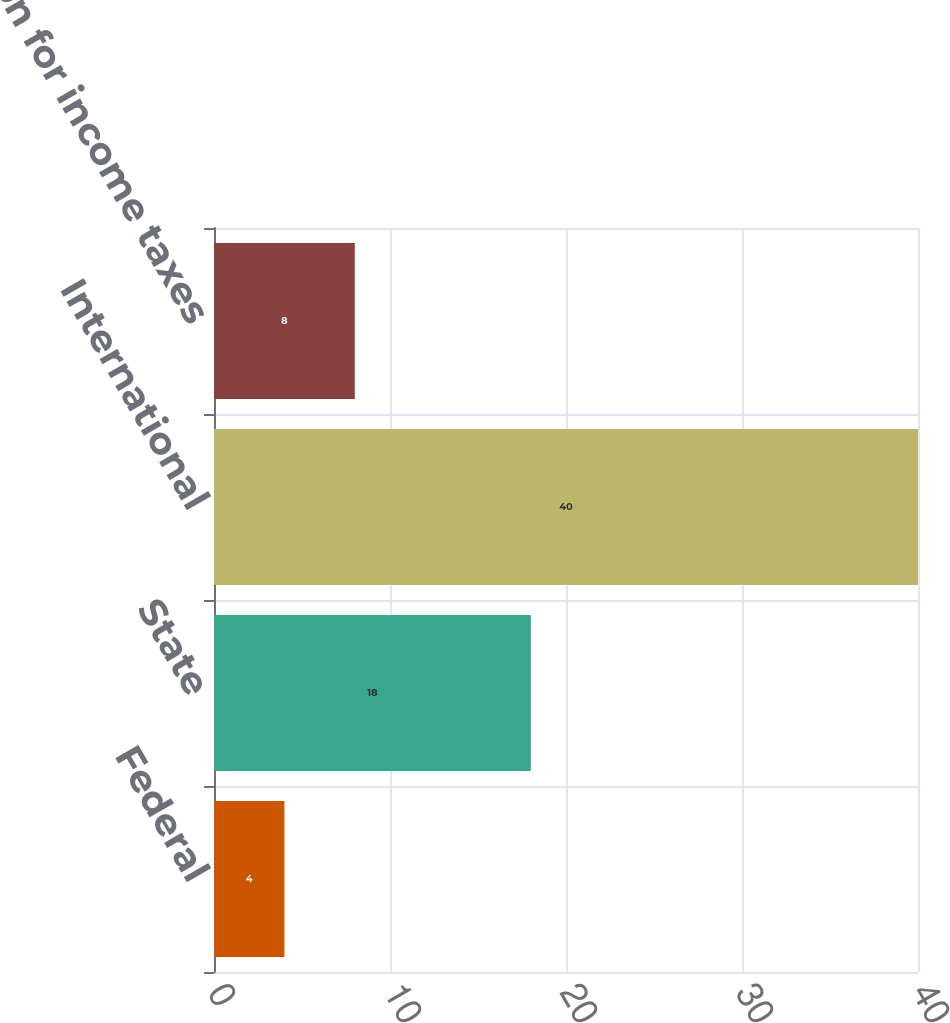<chart> <loc_0><loc_0><loc_500><loc_500><bar_chart><fcel>Federal<fcel>State<fcel>International<fcel>Provision for income taxes<nl><fcel>4<fcel>18<fcel>40<fcel>8<nl></chart> 